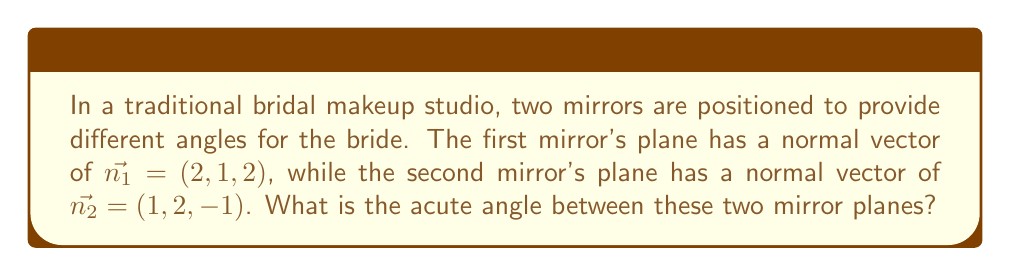Can you answer this question? To find the angle between two planes, we can use the dot product of their normal vectors. The formula for the angle $\theta$ between two planes with normal vectors $\vec{n_1}$ and $\vec{n_2}$ is:

$$\cos \theta = \frac{|\vec{n_1} \cdot \vec{n_2}|}{\|\vec{n_1}\| \|\vec{n_2}\|}$$

Step 1: Calculate the dot product $\vec{n_1} \cdot \vec{n_2}$
$$\vec{n_1} \cdot \vec{n_2} = (2)(1) + (1)(2) + (2)(-1) = 2 + 2 - 2 = 2$$

Step 2: Calculate the magnitudes of $\vec{n_1}$ and $\vec{n_2}$
$$\|\vec{n_1}\| = \sqrt{2^2 + 1^2 + 2^2} = \sqrt{9} = 3$$
$$\|\vec{n_2}\| = \sqrt{1^2 + 2^2 + (-1)^2} = \sqrt{6}$$

Step 3: Apply the formula
$$\cos \theta = \frac{|2|}{3\sqrt{6}} = \frac{2}{3\sqrt{6}}$$

Step 4: Take the inverse cosine (arccos) of both sides
$$\theta = \arccos\left(\frac{2}{3\sqrt{6}}\right)$$

Step 5: Calculate the result (in radians)
$$\theta \approx 1.3181 \text{ radians}$$

Step 6: Convert to degrees
$$\theta \approx 75.52°$$

[asy]
import geometry;

size(200);
pair O=(0,0);
pair A=(2,3);
pair B=(3,-1);

draw(O--A,Arrow);
draw(O--B,Arrow);

label("$\vec{n_1}$", A, NE);
label("$\vec{n_2}$", B, SE);
label("$\theta$", (0,0), N);

draw(arc(O,0.5,0,75.52), Arrow);
[/asy]
Answer: $75.52°$ 